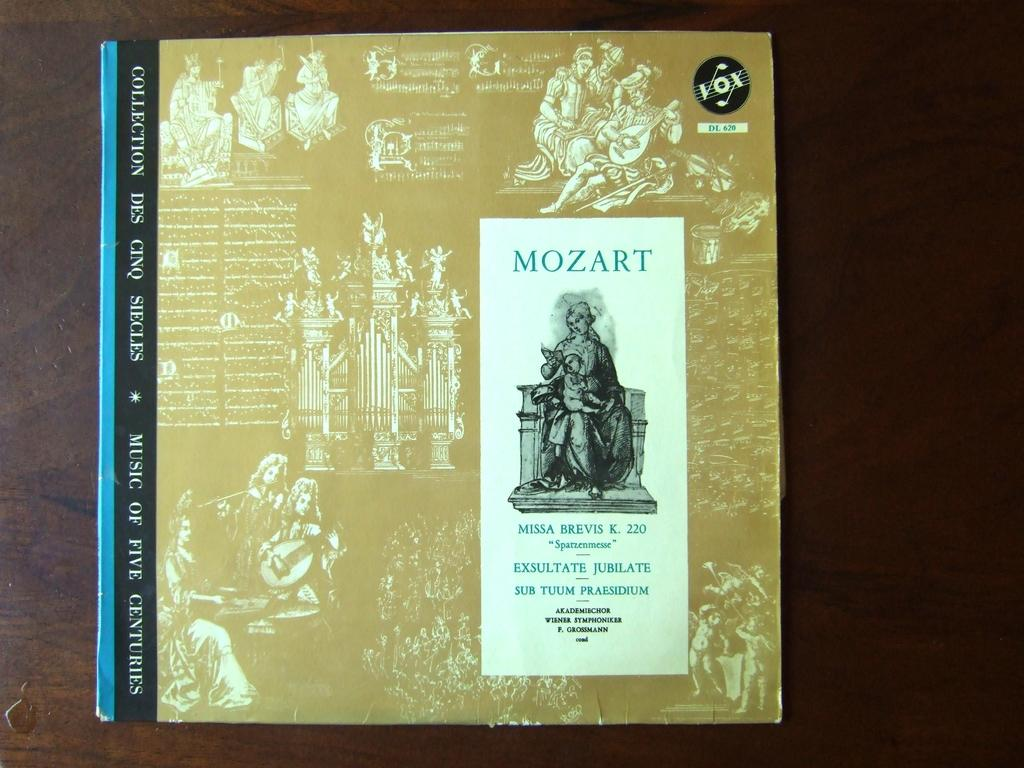<image>
Relay a brief, clear account of the picture shown. An album from the classical musician Mozart hosts a collection of songs. 